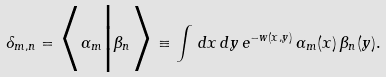Convert formula to latex. <formula><loc_0><loc_0><loc_500><loc_500>\delta _ { m , n } = \Big < \alpha _ { m } \Big | \beta _ { n } \Big > \equiv \int \, d x \, d y \, e ^ { - w ( x , y ) } \, \alpha _ { m } ( x ) \, \beta _ { n } ( y ) .</formula> 